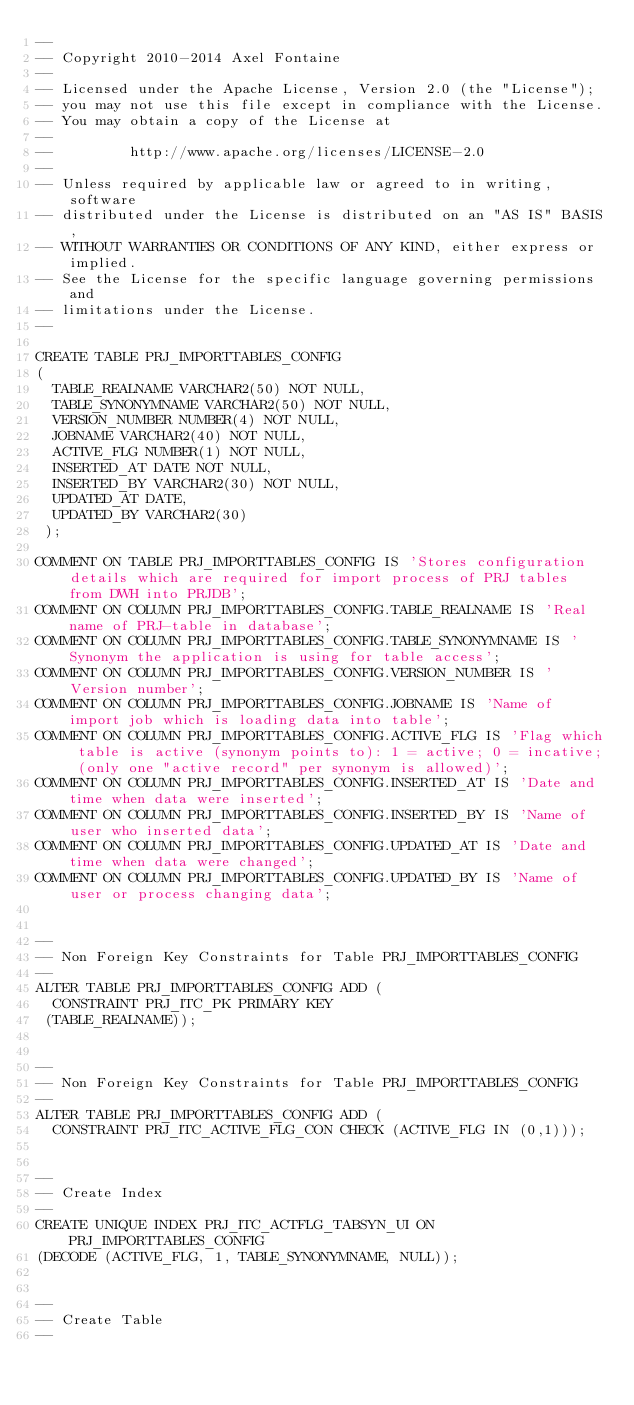Convert code to text. <code><loc_0><loc_0><loc_500><loc_500><_SQL_>--
-- Copyright 2010-2014 Axel Fontaine
--
-- Licensed under the Apache License, Version 2.0 (the "License");
-- you may not use this file except in compliance with the License.
-- You may obtain a copy of the License at
--
--         http://www.apache.org/licenses/LICENSE-2.0
--
-- Unless required by applicable law or agreed to in writing, software
-- distributed under the License is distributed on an "AS IS" BASIS,
-- WITHOUT WARRANTIES OR CONDITIONS OF ANY KIND, either express or implied.
-- See the License for the specific language governing permissions and
-- limitations under the License.
--

CREATE TABLE PRJ_IMPORTTABLES_CONFIG
(
  TABLE_REALNAME VARCHAR2(50) NOT NULL,
  TABLE_SYNONYMNAME VARCHAR2(50) NOT NULL,
  VERSION_NUMBER NUMBER(4) NOT NULL,
  JOBNAME VARCHAR2(40) NOT NULL,
  ACTIVE_FLG NUMBER(1) NOT NULL,
  INSERTED_AT DATE NOT NULL,
  INSERTED_BY VARCHAR2(30) NOT NULL,
  UPDATED_AT DATE,
  UPDATED_BY VARCHAR2(30)
 );

COMMENT ON TABLE PRJ_IMPORTTABLES_CONFIG IS 'Stores configuration details which are required for import process of PRJ tables from DWH into PRJDB';
COMMENT ON COLUMN PRJ_IMPORTTABLES_CONFIG.TABLE_REALNAME IS 'Real name of PRJ-table in database';
COMMENT ON COLUMN PRJ_IMPORTTABLES_CONFIG.TABLE_SYNONYMNAME IS 'Synonym the application is using for table access';
COMMENT ON COLUMN PRJ_IMPORTTABLES_CONFIG.VERSION_NUMBER IS 'Version number';
COMMENT ON COLUMN PRJ_IMPORTTABLES_CONFIG.JOBNAME IS 'Name of import job which is loading data into table';
COMMENT ON COLUMN PRJ_IMPORTTABLES_CONFIG.ACTIVE_FLG IS 'Flag which table is active (synonym points to): 1 = active; 0 = incative; (only one "active record" per synonym is allowed)';
COMMENT ON COLUMN PRJ_IMPORTTABLES_CONFIG.INSERTED_AT IS 'Date and time when data were inserted';
COMMENT ON COLUMN PRJ_IMPORTTABLES_CONFIG.INSERTED_BY IS 'Name of user who inserted data';
COMMENT ON COLUMN PRJ_IMPORTTABLES_CONFIG.UPDATED_AT IS 'Date and time when data were changed';
COMMENT ON COLUMN PRJ_IMPORTTABLES_CONFIG.UPDATED_BY IS 'Name of user or process changing data';


--
-- Non Foreign Key Constraints for Table PRJ_IMPORTTABLES_CONFIG
--
ALTER TABLE PRJ_IMPORTTABLES_CONFIG ADD (
  CONSTRAINT PRJ_ITC_PK PRIMARY KEY
 (TABLE_REALNAME));


--
-- Non Foreign Key Constraints for Table PRJ_IMPORTTABLES_CONFIG
--
ALTER TABLE PRJ_IMPORTTABLES_CONFIG ADD (
  CONSTRAINT PRJ_ITC_ACTIVE_FLG_CON CHECK (ACTIVE_FLG IN (0,1)));


--
-- Create Index
--
CREATE UNIQUE INDEX PRJ_ITC_ACTFLG_TABSYN_UI ON PRJ_IMPORTTABLES_CONFIG
(DECODE (ACTIVE_FLG, 1, TABLE_SYNONYMNAME, NULL));


--
-- Create Table
--</code> 